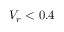<formula> <loc_0><loc_0><loc_500><loc_500>V _ { r } < 0 . 4</formula> 